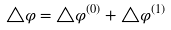Convert formula to latex. <formula><loc_0><loc_0><loc_500><loc_500>\triangle \varphi = \triangle \varphi ^ { ( 0 ) } + \triangle \varphi ^ { ( 1 ) }</formula> 